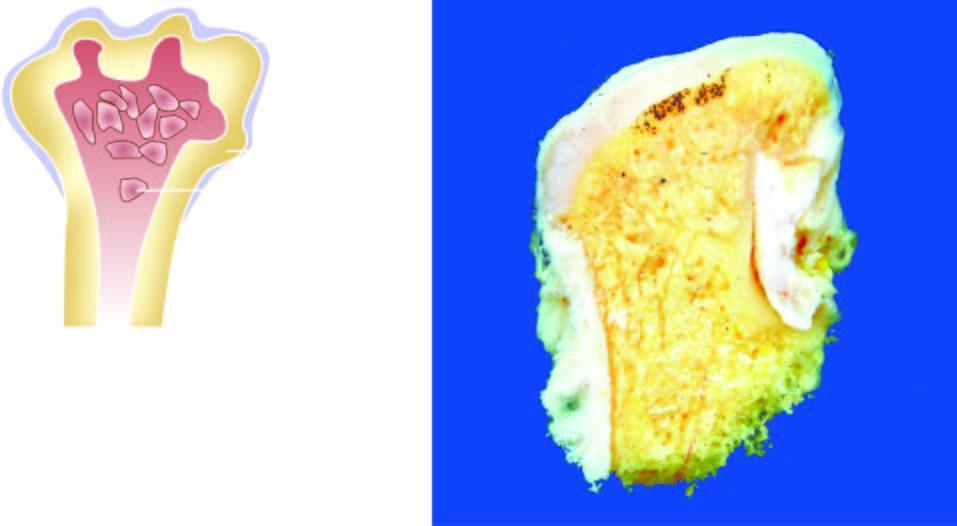does the deposition show mushroom-shaped elevated nodular areas?
Answer the question using a single word or phrase. No 